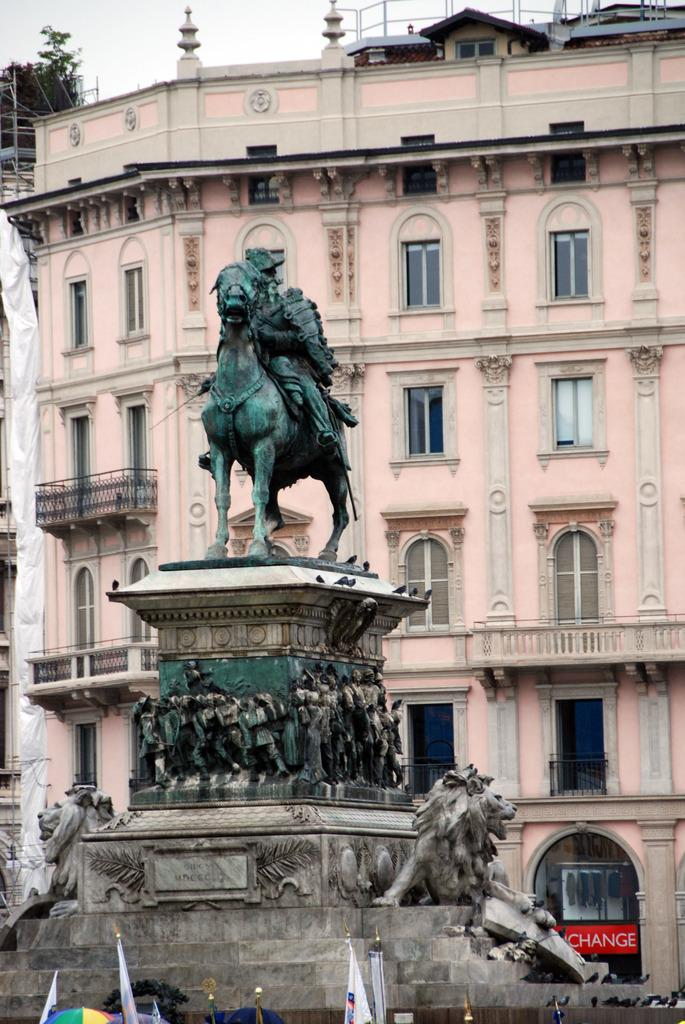<image>
Relay a brief, clear account of the picture shown. Large statue of a man on a horse in front of a building that has a red sign saying CHANGE. 